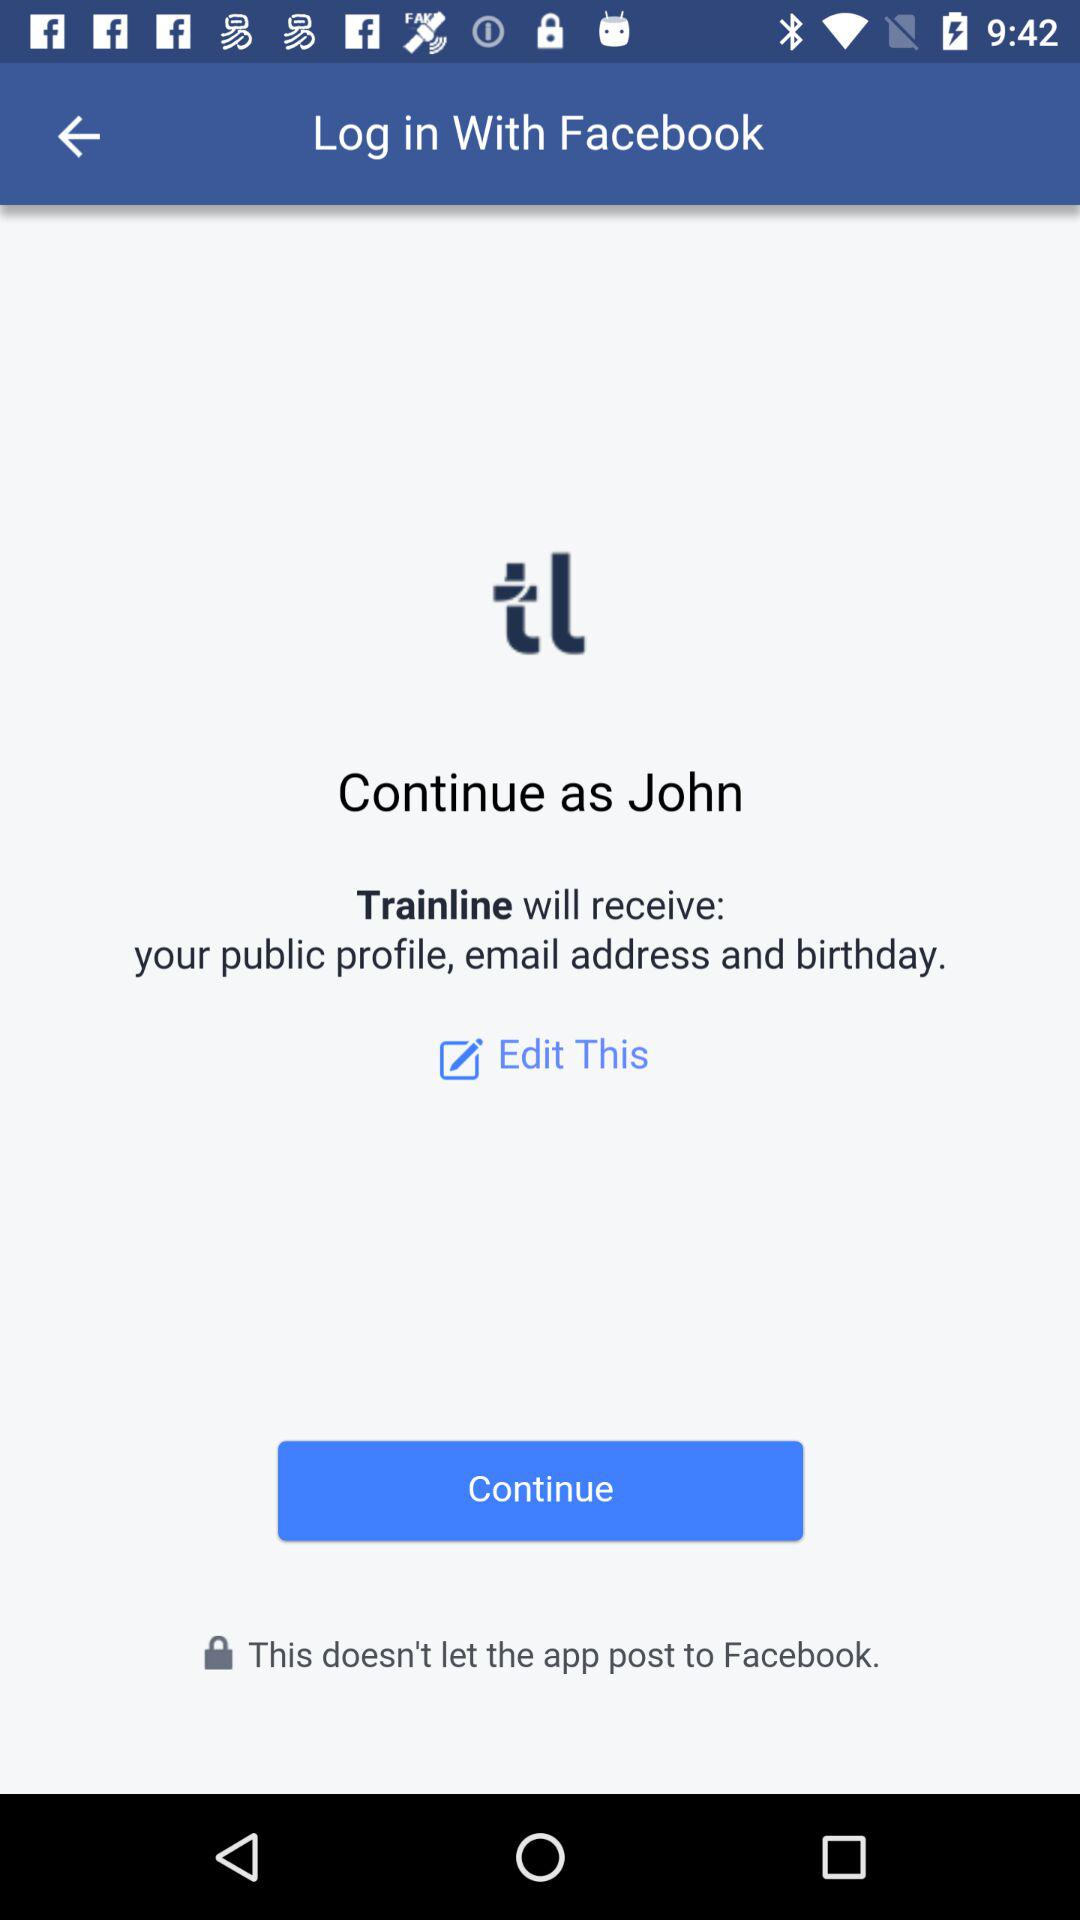What is the user name? The user name is John. 